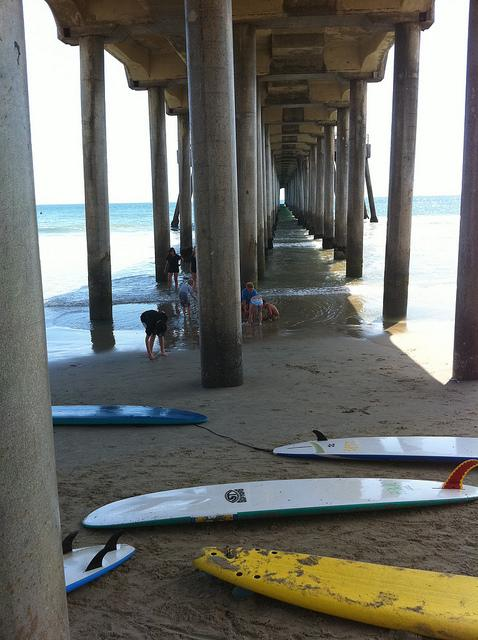What colour is the board on the bottom right? yellow 